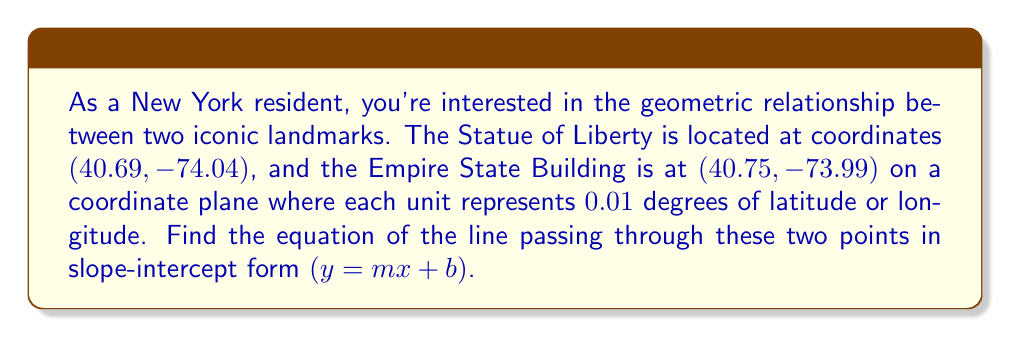Show me your answer to this math problem. Let's approach this step-by-step:

1) First, we need to identify our two points:
   Point 1 (Statue of Liberty): $(x_1, y_1) = (40.69, -74.04)$
   Point 2 (Empire State Building): $(x_2, y_2) = (40.75, -73.99)$

2) To find the equation of a line in slope-intercept form $(y = mx + b)$, we need to calculate the slope $(m)$ and y-intercept $(b)$.

3) Let's start with the slope. The formula for slope is:

   $$m = \frac{y_2 - y_1}{x_2 - x_1}$$

4) Plugging in our values:

   $$m = \frac{-73.99 - (-74.04)}{40.75 - 40.69} = \frac{0.05}{0.06} = \frac{5}{6} \approx 0.8333$$

5) Now that we have the slope, we can use the point-slope form of a line to find the y-intercept. Let's use the first point (40.69, -74.04). The point-slope form is:

   $$y - y_1 = m(x - x_1)$$

6) Substituting our values:

   $$y - (-74.04) = \frac{5}{6}(x - 40.69)$$

7) Simplify:

   $$y + 74.04 = \frac{5}{6}x - \frac{5}{6}(40.69)$$
   $$y = \frac{5}{6}x - \frac{5}{6}(40.69) - 74.04$$

8) Simplify further:

   $$y = \frac{5}{6}x - 33.9083 - 74.04$$
   $$y = \frac{5}{6}x - 107.9483$$

9) This is now in slope-intercept form $(y = mx + b)$, where $m = \frac{5}{6}$ and $b = -107.9483$.
Answer: The equation of the line passing through the Statue of Liberty and the Empire State Building is:

$$y = \frac{5}{6}x - 107.9483$$

where $x$ and $y$ represent longitude and latitude, respectively, in units of 0.01 degrees. 